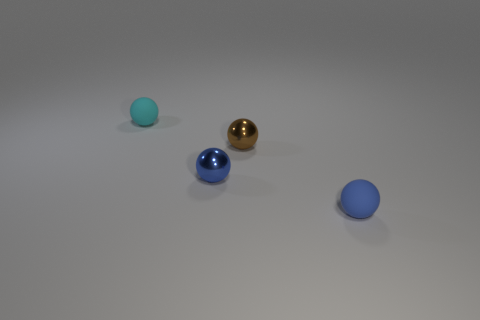How many blue balls must be subtracted to get 1 blue balls? 1 Subtract 1 spheres. How many spheres are left? 3 Add 1 small blue spheres. How many objects exist? 5 Add 3 small shiny spheres. How many small shiny spheres are left? 5 Add 2 tiny brown metallic spheres. How many tiny brown metallic spheres exist? 3 Subtract 1 cyan balls. How many objects are left? 3 Subtract all matte balls. Subtract all metal spheres. How many objects are left? 0 